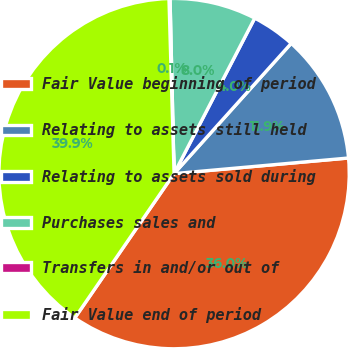Convert chart. <chart><loc_0><loc_0><loc_500><loc_500><pie_chart><fcel>Fair Value beginning of period<fcel>Relating to assets still held<fcel>Relating to assets sold during<fcel>Purchases sales and<fcel>Transfers in and/or out of<fcel>Fair Value end of period<nl><fcel>36.0%<fcel>11.92%<fcel>4.04%<fcel>7.98%<fcel>0.1%<fcel>39.94%<nl></chart> 